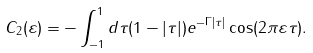<formula> <loc_0><loc_0><loc_500><loc_500>C _ { 2 } ( \varepsilon ) = - \int _ { - 1 } ^ { 1 } d \tau ( 1 - | \tau | ) e ^ { - \Gamma | \tau | } \cos ( 2 \pi \varepsilon \tau ) .</formula> 